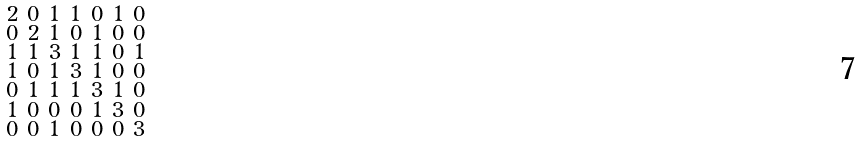Convert formula to latex. <formula><loc_0><loc_0><loc_500><loc_500>\begin{smallmatrix} 2 & 0 & 1 & 1 & 0 & 1 & 0 \\ 0 & 2 & 1 & 0 & 1 & 0 & 0 \\ 1 & 1 & 3 & 1 & 1 & 0 & 1 \\ 1 & 0 & 1 & 3 & 1 & 0 & 0 \\ 0 & 1 & 1 & 1 & 3 & 1 & 0 \\ 1 & 0 & 0 & 0 & 1 & 3 & 0 \\ 0 & 0 & 1 & 0 & 0 & 0 & 3 \end{smallmatrix}</formula> 